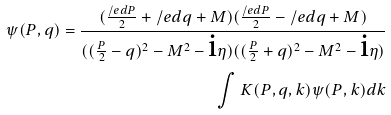<formula> <loc_0><loc_0><loc_500><loc_500>\psi ( P , q ) = \frac { ( \frac { \slash e d { P } } { 2 } + \slash e d { q } + M ) ( \frac { \slash e d { P } } { 2 } - \slash e d { q } + M ) } { ( ( \frac { P } { 2 } - q ) ^ { 2 } - M ^ { 2 } - \text {i} \eta ) ( ( \frac { P } { 2 } + q ) ^ { 2 } - M ^ { 2 } - \text {i} \eta ) } \\ \int { K ( P , q , k ) \psi ( P , k ) d k }</formula> 